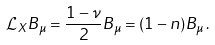<formula> <loc_0><loc_0><loc_500><loc_500>\mathcal { L } _ { X } B _ { \mu } = \frac { 1 - \nu } { 2 } B _ { \mu } = ( 1 - n ) B _ { \mu } \, .</formula> 